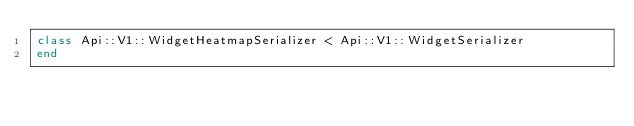Convert code to text. <code><loc_0><loc_0><loc_500><loc_500><_Ruby_>class Api::V1::WidgetHeatmapSerializer < Api::V1::WidgetSerializer
end
</code> 